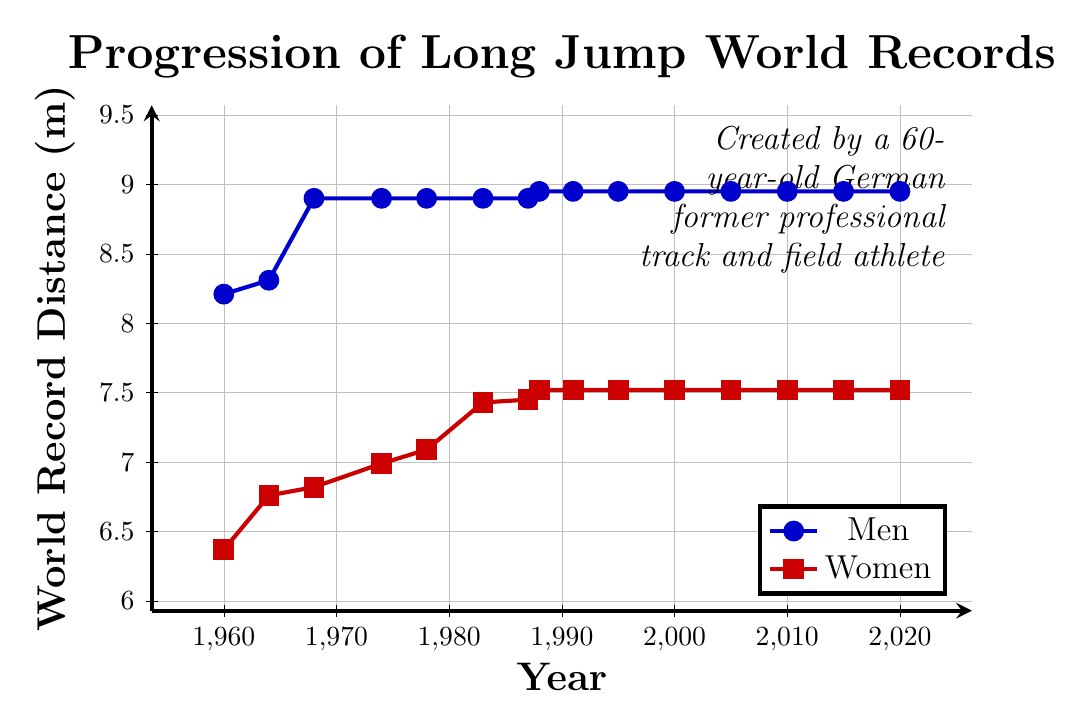What's the world record distance for men's long jump in 1968? To find the men's world record distance in 1968, look for the point on the men's line graph corresponding to the year 1968.
Answer: 8.90 What's the difference between the men's and women's world record distances in 1988? To determine the difference in 1988, subtract the women's world record distance from the men's distance for that year. Men's is 8.95 m and women's is 7.52 m, so 8.95 - 7.52.
Answer: 1.43 In which year did men's and women's world records both achieve their longest distance gap? Identify the year with the maximum gap by comparing the two lines over time. The largest gap is noticed when men's record is 8.95 m (from 1988 onwards) and women's record is 6.37 m in 1960, giving a gap of 2.58 m. However, the graphical consistency shows significant gaps between data points in 1988 when men reached 8.95 m and women were at 7.52 m, but the largest separation is between intervals during early years before they both plateau.
Answer: 1960 How many years did the men's world record remain stagnant from 1968 onward? From the year 1968 onward, identify each period when there is no increase in the men's world record. It remains 8.90 m from 1968 till 1988 and then 8.95 m from 1988 to 2020. Two stagnant periods are 20 years (1968 to 1988) and 32 years (1988 to 2020).
Answer: 52 Between 1983 and 1987, by how much did the women's world record increase? Calculate the difference between the women's world record in 1987 and in 1983. The women's world record in 1983 is 7.43 m, and in 1987 it is 7.45 m.
Answer: 0.02 Which gender had a steeper increase in their world record distance between 1964 and 1978? To determine which gender had a steeper increase, calculate the slope of the increase for both genders over this period. Men's increase: 8.31 m to 8.90 m (0.59 m), Women's increase: 6.76 m to 7.09 m (0.33 m). Compare the rates.
Answer: Men What are the colors used to represent men's and women's world records in the graph? Refer to the visual attributes used in the chart. The men's data line is marked with blue, and the women's data line is marked with red.
Answer: Blue for Men, Red for Women During which decade did the women's world record see its most significant improvement? Look at the changes between consecutive points in the women's world record line graph to find the decade with the most significant increase. The largest improvement in the women's record occurred in the period 1983-1988, where it increased from 7.43 m to 7.52 m.
Answer: 1980s 